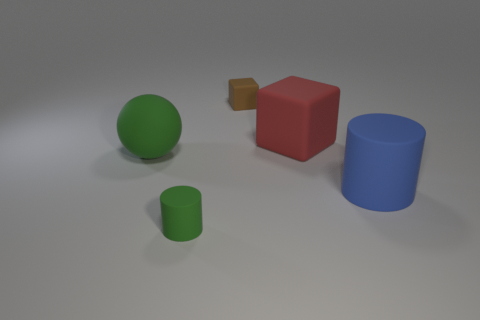Is the brown object the same size as the green cylinder?
Make the answer very short. Yes. There is a small matte thing in front of the small object to the right of the tiny rubber thing in front of the ball; what is its shape?
Offer a terse response. Cylinder. The tiny matte thing that is the same shape as the large red matte object is what color?
Offer a terse response. Brown. There is a matte thing that is both behind the big green rubber sphere and in front of the small matte cube; what size is it?
Provide a short and direct response. Large. There is a tiny object that is left of the rubber cube behind the large red cube; what number of tiny brown rubber blocks are behind it?
Ensure brevity in your answer.  1. How many small things are either blue balls or blue rubber objects?
Keep it short and to the point. 0. What number of metal things are either big objects or big cylinders?
Give a very brief answer. 0. Is there a tiny gray sphere?
Your answer should be compact. No. What color is the cylinder in front of the big matte thing that is in front of the ball?
Make the answer very short. Green. What number of other things are the same color as the matte sphere?
Provide a short and direct response. 1. 